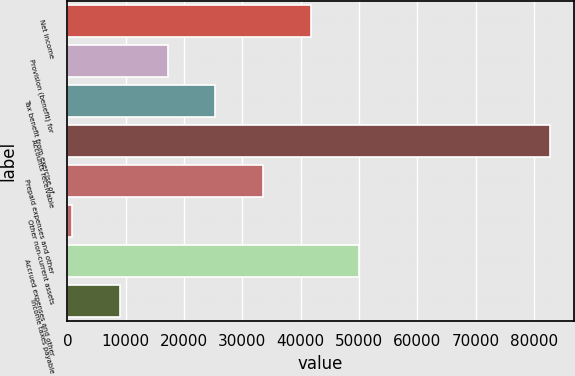Convert chart to OTSL. <chart><loc_0><loc_0><loc_500><loc_500><bar_chart><fcel>Net income<fcel>Provision (benefit) for<fcel>Tax benefit from exercise of<fcel>Accounts receivable<fcel>Prepaid expenses and other<fcel>Other non-current assets<fcel>Accrued expenses and other<fcel>Income taxes payable<nl><fcel>41753.5<fcel>17199.4<fcel>25384.1<fcel>82677<fcel>33568.8<fcel>830<fcel>49938.2<fcel>9014.7<nl></chart> 